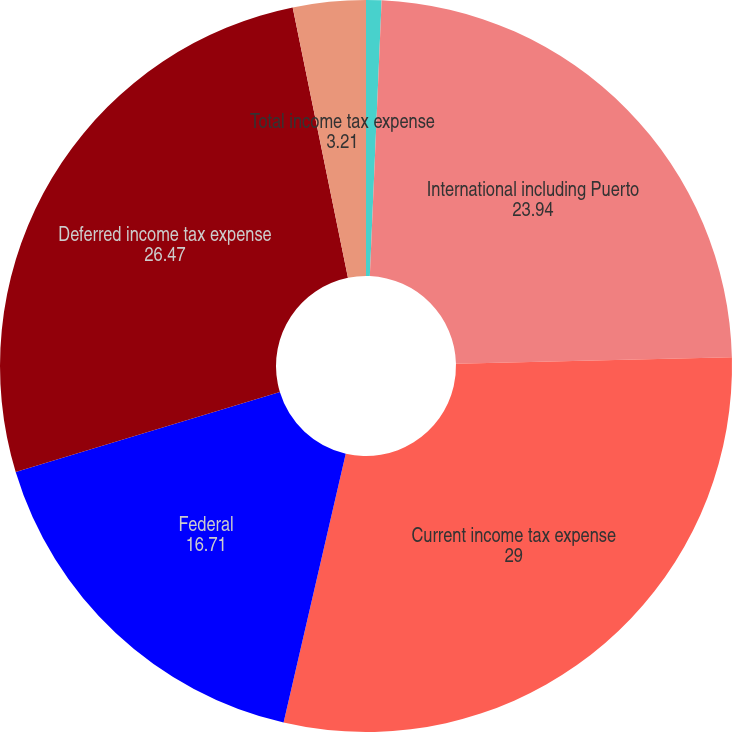Convert chart. <chart><loc_0><loc_0><loc_500><loc_500><pie_chart><fcel>State and local<fcel>International including Puerto<fcel>Current income tax expense<fcel>Federal<fcel>Deferred income tax expense<fcel>Total income tax expense<nl><fcel>0.68%<fcel>23.94%<fcel>29.0%<fcel>16.71%<fcel>26.47%<fcel>3.21%<nl></chart> 